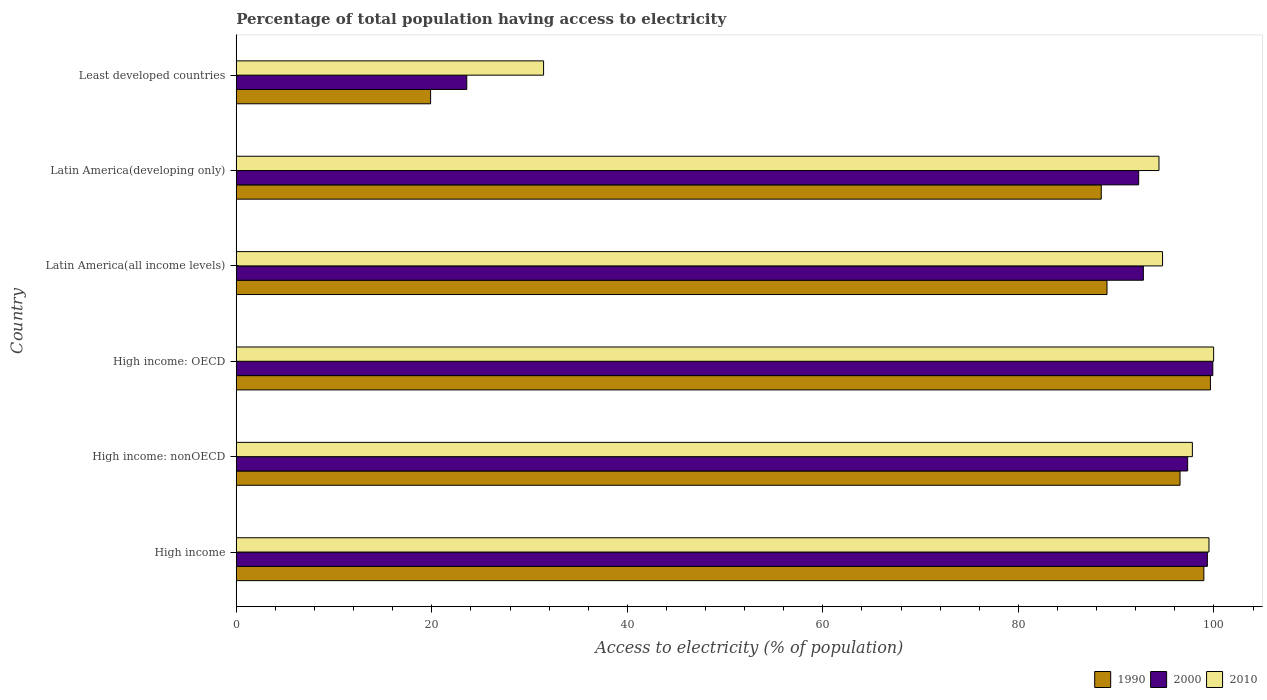Are the number of bars on each tick of the Y-axis equal?
Give a very brief answer. Yes. How many bars are there on the 3rd tick from the top?
Your answer should be very brief. 3. How many bars are there on the 2nd tick from the bottom?
Provide a short and direct response. 3. What is the label of the 2nd group of bars from the top?
Provide a succinct answer. Latin America(developing only). What is the percentage of population that have access to electricity in 1990 in Latin America(developing only)?
Make the answer very short. 88.48. Across all countries, what is the maximum percentage of population that have access to electricity in 2010?
Your answer should be compact. 99.97. Across all countries, what is the minimum percentage of population that have access to electricity in 2010?
Keep it short and to the point. 31.44. In which country was the percentage of population that have access to electricity in 2000 maximum?
Provide a succinct answer. High income: OECD. In which country was the percentage of population that have access to electricity in 2000 minimum?
Keep it short and to the point. Least developed countries. What is the total percentage of population that have access to electricity in 2000 in the graph?
Offer a very short reply. 505.2. What is the difference between the percentage of population that have access to electricity in 1990 in Latin America(all income levels) and that in Latin America(developing only)?
Offer a very short reply. 0.59. What is the difference between the percentage of population that have access to electricity in 2010 in High income: OECD and the percentage of population that have access to electricity in 2000 in Least developed countries?
Provide a short and direct response. 76.39. What is the average percentage of population that have access to electricity in 2010 per country?
Provide a short and direct response. 86.3. What is the difference between the percentage of population that have access to electricity in 2000 and percentage of population that have access to electricity in 2010 in Least developed countries?
Provide a succinct answer. -7.86. In how many countries, is the percentage of population that have access to electricity in 2010 greater than 88 %?
Make the answer very short. 5. What is the ratio of the percentage of population that have access to electricity in 2010 in Latin America(all income levels) to that in Least developed countries?
Ensure brevity in your answer.  3.01. What is the difference between the highest and the second highest percentage of population that have access to electricity in 1990?
Provide a short and direct response. 0.67. What is the difference between the highest and the lowest percentage of population that have access to electricity in 2000?
Offer a very short reply. 76.31. What does the 2nd bar from the top in Latin America(developing only) represents?
Make the answer very short. 2000. What does the 1st bar from the bottom in High income: nonOECD represents?
Make the answer very short. 1990. Is it the case that in every country, the sum of the percentage of population that have access to electricity in 2000 and percentage of population that have access to electricity in 1990 is greater than the percentage of population that have access to electricity in 2010?
Ensure brevity in your answer.  Yes. How many bars are there?
Make the answer very short. 18. Are all the bars in the graph horizontal?
Your answer should be very brief. Yes. How many countries are there in the graph?
Give a very brief answer. 6. What is the difference between two consecutive major ticks on the X-axis?
Provide a succinct answer. 20. Are the values on the major ticks of X-axis written in scientific E-notation?
Ensure brevity in your answer.  No. Does the graph contain any zero values?
Provide a succinct answer. No. Does the graph contain grids?
Ensure brevity in your answer.  No. How many legend labels are there?
Offer a very short reply. 3. How are the legend labels stacked?
Provide a short and direct response. Horizontal. What is the title of the graph?
Make the answer very short. Percentage of total population having access to electricity. Does "1960" appear as one of the legend labels in the graph?
Ensure brevity in your answer.  No. What is the label or title of the X-axis?
Offer a very short reply. Access to electricity (% of population). What is the Access to electricity (% of population) of 1990 in High income?
Provide a short and direct response. 98.97. What is the Access to electricity (% of population) in 2000 in High income?
Provide a short and direct response. 99.33. What is the Access to electricity (% of population) in 2010 in High income?
Ensure brevity in your answer.  99.49. What is the Access to electricity (% of population) of 1990 in High income: nonOECD?
Give a very brief answer. 96.53. What is the Access to electricity (% of population) in 2000 in High income: nonOECD?
Offer a terse response. 97.31. What is the Access to electricity (% of population) of 2010 in High income: nonOECD?
Give a very brief answer. 97.8. What is the Access to electricity (% of population) of 1990 in High income: OECD?
Provide a short and direct response. 99.64. What is the Access to electricity (% of population) of 2000 in High income: OECD?
Offer a terse response. 99.89. What is the Access to electricity (% of population) of 2010 in High income: OECD?
Your answer should be very brief. 99.97. What is the Access to electricity (% of population) in 1990 in Latin America(all income levels)?
Give a very brief answer. 89.06. What is the Access to electricity (% of population) of 2000 in Latin America(all income levels)?
Your answer should be compact. 92.78. What is the Access to electricity (% of population) in 2010 in Latin America(all income levels)?
Keep it short and to the point. 94.75. What is the Access to electricity (% of population) of 1990 in Latin America(developing only)?
Your answer should be very brief. 88.48. What is the Access to electricity (% of population) in 2000 in Latin America(developing only)?
Your answer should be very brief. 92.3. What is the Access to electricity (% of population) of 2010 in Latin America(developing only)?
Your answer should be very brief. 94.38. What is the Access to electricity (% of population) of 1990 in Least developed countries?
Ensure brevity in your answer.  19.88. What is the Access to electricity (% of population) of 2000 in Least developed countries?
Your answer should be very brief. 23.58. What is the Access to electricity (% of population) in 2010 in Least developed countries?
Provide a succinct answer. 31.44. Across all countries, what is the maximum Access to electricity (% of population) in 1990?
Provide a succinct answer. 99.64. Across all countries, what is the maximum Access to electricity (% of population) in 2000?
Keep it short and to the point. 99.89. Across all countries, what is the maximum Access to electricity (% of population) in 2010?
Offer a very short reply. 99.97. Across all countries, what is the minimum Access to electricity (% of population) in 1990?
Provide a succinct answer. 19.88. Across all countries, what is the minimum Access to electricity (% of population) in 2000?
Your answer should be compact. 23.58. Across all countries, what is the minimum Access to electricity (% of population) in 2010?
Keep it short and to the point. 31.44. What is the total Access to electricity (% of population) of 1990 in the graph?
Ensure brevity in your answer.  492.57. What is the total Access to electricity (% of population) in 2000 in the graph?
Make the answer very short. 505.2. What is the total Access to electricity (% of population) of 2010 in the graph?
Offer a terse response. 517.82. What is the difference between the Access to electricity (% of population) of 1990 in High income and that in High income: nonOECD?
Your response must be concise. 2.44. What is the difference between the Access to electricity (% of population) in 2000 in High income and that in High income: nonOECD?
Give a very brief answer. 2.02. What is the difference between the Access to electricity (% of population) of 2010 in High income and that in High income: nonOECD?
Offer a very short reply. 1.7. What is the difference between the Access to electricity (% of population) of 1990 in High income and that in High income: OECD?
Give a very brief answer. -0.67. What is the difference between the Access to electricity (% of population) in 2000 in High income and that in High income: OECD?
Your response must be concise. -0.56. What is the difference between the Access to electricity (% of population) of 2010 in High income and that in High income: OECD?
Your answer should be compact. -0.48. What is the difference between the Access to electricity (% of population) of 1990 in High income and that in Latin America(all income levels)?
Your answer should be compact. 9.91. What is the difference between the Access to electricity (% of population) of 2000 in High income and that in Latin America(all income levels)?
Your answer should be compact. 6.55. What is the difference between the Access to electricity (% of population) of 2010 in High income and that in Latin America(all income levels)?
Keep it short and to the point. 4.75. What is the difference between the Access to electricity (% of population) of 1990 in High income and that in Latin America(developing only)?
Provide a succinct answer. 10.49. What is the difference between the Access to electricity (% of population) in 2000 in High income and that in Latin America(developing only)?
Provide a succinct answer. 7.03. What is the difference between the Access to electricity (% of population) of 2010 in High income and that in Latin America(developing only)?
Ensure brevity in your answer.  5.12. What is the difference between the Access to electricity (% of population) in 1990 in High income and that in Least developed countries?
Offer a terse response. 79.09. What is the difference between the Access to electricity (% of population) of 2000 in High income and that in Least developed countries?
Your answer should be compact. 75.75. What is the difference between the Access to electricity (% of population) in 2010 in High income and that in Least developed countries?
Provide a succinct answer. 68.06. What is the difference between the Access to electricity (% of population) of 1990 in High income: nonOECD and that in High income: OECD?
Give a very brief answer. -3.11. What is the difference between the Access to electricity (% of population) of 2000 in High income: nonOECD and that in High income: OECD?
Ensure brevity in your answer.  -2.57. What is the difference between the Access to electricity (% of population) of 2010 in High income: nonOECD and that in High income: OECD?
Offer a terse response. -2.17. What is the difference between the Access to electricity (% of population) of 1990 in High income: nonOECD and that in Latin America(all income levels)?
Give a very brief answer. 7.47. What is the difference between the Access to electricity (% of population) of 2000 in High income: nonOECD and that in Latin America(all income levels)?
Provide a short and direct response. 4.53. What is the difference between the Access to electricity (% of population) in 2010 in High income: nonOECD and that in Latin America(all income levels)?
Give a very brief answer. 3.05. What is the difference between the Access to electricity (% of population) of 1990 in High income: nonOECD and that in Latin America(developing only)?
Ensure brevity in your answer.  8.06. What is the difference between the Access to electricity (% of population) of 2000 in High income: nonOECD and that in Latin America(developing only)?
Your answer should be very brief. 5.01. What is the difference between the Access to electricity (% of population) in 2010 in High income: nonOECD and that in Latin America(developing only)?
Provide a succinct answer. 3.42. What is the difference between the Access to electricity (% of population) of 1990 in High income: nonOECD and that in Least developed countries?
Provide a short and direct response. 76.66. What is the difference between the Access to electricity (% of population) of 2000 in High income: nonOECD and that in Least developed countries?
Ensure brevity in your answer.  73.73. What is the difference between the Access to electricity (% of population) in 2010 in High income: nonOECD and that in Least developed countries?
Offer a terse response. 66.36. What is the difference between the Access to electricity (% of population) of 1990 in High income: OECD and that in Latin America(all income levels)?
Provide a short and direct response. 10.58. What is the difference between the Access to electricity (% of population) of 2000 in High income: OECD and that in Latin America(all income levels)?
Make the answer very short. 7.1. What is the difference between the Access to electricity (% of population) of 2010 in High income: OECD and that in Latin America(all income levels)?
Make the answer very short. 5.22. What is the difference between the Access to electricity (% of population) of 1990 in High income: OECD and that in Latin America(developing only)?
Provide a short and direct response. 11.17. What is the difference between the Access to electricity (% of population) of 2000 in High income: OECD and that in Latin America(developing only)?
Ensure brevity in your answer.  7.58. What is the difference between the Access to electricity (% of population) of 2010 in High income: OECD and that in Latin America(developing only)?
Provide a succinct answer. 5.59. What is the difference between the Access to electricity (% of population) in 1990 in High income: OECD and that in Least developed countries?
Offer a terse response. 79.77. What is the difference between the Access to electricity (% of population) in 2000 in High income: OECD and that in Least developed countries?
Keep it short and to the point. 76.31. What is the difference between the Access to electricity (% of population) in 2010 in High income: OECD and that in Least developed countries?
Offer a terse response. 68.53. What is the difference between the Access to electricity (% of population) of 1990 in Latin America(all income levels) and that in Latin America(developing only)?
Ensure brevity in your answer.  0.59. What is the difference between the Access to electricity (% of population) in 2000 in Latin America(all income levels) and that in Latin America(developing only)?
Your answer should be compact. 0.48. What is the difference between the Access to electricity (% of population) in 2010 in Latin America(all income levels) and that in Latin America(developing only)?
Your answer should be very brief. 0.37. What is the difference between the Access to electricity (% of population) of 1990 in Latin America(all income levels) and that in Least developed countries?
Your answer should be very brief. 69.19. What is the difference between the Access to electricity (% of population) in 2000 in Latin America(all income levels) and that in Least developed countries?
Your response must be concise. 69.2. What is the difference between the Access to electricity (% of population) of 2010 in Latin America(all income levels) and that in Least developed countries?
Keep it short and to the point. 63.31. What is the difference between the Access to electricity (% of population) of 1990 in Latin America(developing only) and that in Least developed countries?
Provide a succinct answer. 68.6. What is the difference between the Access to electricity (% of population) in 2000 in Latin America(developing only) and that in Least developed countries?
Offer a terse response. 68.72. What is the difference between the Access to electricity (% of population) in 2010 in Latin America(developing only) and that in Least developed countries?
Keep it short and to the point. 62.94. What is the difference between the Access to electricity (% of population) of 1990 in High income and the Access to electricity (% of population) of 2000 in High income: nonOECD?
Your answer should be compact. 1.66. What is the difference between the Access to electricity (% of population) in 1990 in High income and the Access to electricity (% of population) in 2010 in High income: nonOECD?
Offer a very short reply. 1.18. What is the difference between the Access to electricity (% of population) of 2000 in High income and the Access to electricity (% of population) of 2010 in High income: nonOECD?
Ensure brevity in your answer.  1.53. What is the difference between the Access to electricity (% of population) of 1990 in High income and the Access to electricity (% of population) of 2000 in High income: OECD?
Your answer should be compact. -0.91. What is the difference between the Access to electricity (% of population) of 1990 in High income and the Access to electricity (% of population) of 2010 in High income: OECD?
Your answer should be compact. -1. What is the difference between the Access to electricity (% of population) of 2000 in High income and the Access to electricity (% of population) of 2010 in High income: OECD?
Provide a succinct answer. -0.64. What is the difference between the Access to electricity (% of population) in 1990 in High income and the Access to electricity (% of population) in 2000 in Latin America(all income levels)?
Ensure brevity in your answer.  6.19. What is the difference between the Access to electricity (% of population) in 1990 in High income and the Access to electricity (% of population) in 2010 in Latin America(all income levels)?
Provide a succinct answer. 4.23. What is the difference between the Access to electricity (% of population) in 2000 in High income and the Access to electricity (% of population) in 2010 in Latin America(all income levels)?
Your response must be concise. 4.59. What is the difference between the Access to electricity (% of population) of 1990 in High income and the Access to electricity (% of population) of 2000 in Latin America(developing only)?
Ensure brevity in your answer.  6.67. What is the difference between the Access to electricity (% of population) in 1990 in High income and the Access to electricity (% of population) in 2010 in Latin America(developing only)?
Offer a very short reply. 4.59. What is the difference between the Access to electricity (% of population) in 2000 in High income and the Access to electricity (% of population) in 2010 in Latin America(developing only)?
Your answer should be very brief. 4.95. What is the difference between the Access to electricity (% of population) in 1990 in High income and the Access to electricity (% of population) in 2000 in Least developed countries?
Give a very brief answer. 75.39. What is the difference between the Access to electricity (% of population) in 1990 in High income and the Access to electricity (% of population) in 2010 in Least developed countries?
Your answer should be compact. 67.54. What is the difference between the Access to electricity (% of population) in 2000 in High income and the Access to electricity (% of population) in 2010 in Least developed countries?
Your answer should be compact. 67.9. What is the difference between the Access to electricity (% of population) of 1990 in High income: nonOECD and the Access to electricity (% of population) of 2000 in High income: OECD?
Ensure brevity in your answer.  -3.35. What is the difference between the Access to electricity (% of population) in 1990 in High income: nonOECD and the Access to electricity (% of population) in 2010 in High income: OECD?
Make the answer very short. -3.44. What is the difference between the Access to electricity (% of population) in 2000 in High income: nonOECD and the Access to electricity (% of population) in 2010 in High income: OECD?
Make the answer very short. -2.66. What is the difference between the Access to electricity (% of population) in 1990 in High income: nonOECD and the Access to electricity (% of population) in 2000 in Latin America(all income levels)?
Make the answer very short. 3.75. What is the difference between the Access to electricity (% of population) in 1990 in High income: nonOECD and the Access to electricity (% of population) in 2010 in Latin America(all income levels)?
Offer a very short reply. 1.79. What is the difference between the Access to electricity (% of population) in 2000 in High income: nonOECD and the Access to electricity (% of population) in 2010 in Latin America(all income levels)?
Make the answer very short. 2.57. What is the difference between the Access to electricity (% of population) in 1990 in High income: nonOECD and the Access to electricity (% of population) in 2000 in Latin America(developing only)?
Your answer should be very brief. 4.23. What is the difference between the Access to electricity (% of population) of 1990 in High income: nonOECD and the Access to electricity (% of population) of 2010 in Latin America(developing only)?
Make the answer very short. 2.16. What is the difference between the Access to electricity (% of population) in 2000 in High income: nonOECD and the Access to electricity (% of population) in 2010 in Latin America(developing only)?
Make the answer very short. 2.94. What is the difference between the Access to electricity (% of population) in 1990 in High income: nonOECD and the Access to electricity (% of population) in 2000 in Least developed countries?
Provide a short and direct response. 72.95. What is the difference between the Access to electricity (% of population) of 1990 in High income: nonOECD and the Access to electricity (% of population) of 2010 in Least developed countries?
Give a very brief answer. 65.1. What is the difference between the Access to electricity (% of population) in 2000 in High income: nonOECD and the Access to electricity (% of population) in 2010 in Least developed countries?
Your answer should be very brief. 65.88. What is the difference between the Access to electricity (% of population) of 1990 in High income: OECD and the Access to electricity (% of population) of 2000 in Latin America(all income levels)?
Your answer should be compact. 6.86. What is the difference between the Access to electricity (% of population) of 1990 in High income: OECD and the Access to electricity (% of population) of 2010 in Latin America(all income levels)?
Give a very brief answer. 4.9. What is the difference between the Access to electricity (% of population) of 2000 in High income: OECD and the Access to electricity (% of population) of 2010 in Latin America(all income levels)?
Offer a very short reply. 5.14. What is the difference between the Access to electricity (% of population) of 1990 in High income: OECD and the Access to electricity (% of population) of 2000 in Latin America(developing only)?
Offer a terse response. 7.34. What is the difference between the Access to electricity (% of population) in 1990 in High income: OECD and the Access to electricity (% of population) in 2010 in Latin America(developing only)?
Your answer should be compact. 5.27. What is the difference between the Access to electricity (% of population) in 2000 in High income: OECD and the Access to electricity (% of population) in 2010 in Latin America(developing only)?
Your answer should be very brief. 5.51. What is the difference between the Access to electricity (% of population) in 1990 in High income: OECD and the Access to electricity (% of population) in 2000 in Least developed countries?
Your answer should be compact. 76.07. What is the difference between the Access to electricity (% of population) in 1990 in High income: OECD and the Access to electricity (% of population) in 2010 in Least developed countries?
Make the answer very short. 68.21. What is the difference between the Access to electricity (% of population) of 2000 in High income: OECD and the Access to electricity (% of population) of 2010 in Least developed countries?
Keep it short and to the point. 68.45. What is the difference between the Access to electricity (% of population) of 1990 in Latin America(all income levels) and the Access to electricity (% of population) of 2000 in Latin America(developing only)?
Offer a very short reply. -3.24. What is the difference between the Access to electricity (% of population) of 1990 in Latin America(all income levels) and the Access to electricity (% of population) of 2010 in Latin America(developing only)?
Your answer should be very brief. -5.32. What is the difference between the Access to electricity (% of population) in 2000 in Latin America(all income levels) and the Access to electricity (% of population) in 2010 in Latin America(developing only)?
Give a very brief answer. -1.6. What is the difference between the Access to electricity (% of population) of 1990 in Latin America(all income levels) and the Access to electricity (% of population) of 2000 in Least developed countries?
Your answer should be very brief. 65.48. What is the difference between the Access to electricity (% of population) in 1990 in Latin America(all income levels) and the Access to electricity (% of population) in 2010 in Least developed countries?
Offer a very short reply. 57.63. What is the difference between the Access to electricity (% of population) in 2000 in Latin America(all income levels) and the Access to electricity (% of population) in 2010 in Least developed countries?
Your answer should be compact. 61.35. What is the difference between the Access to electricity (% of population) in 1990 in Latin America(developing only) and the Access to electricity (% of population) in 2000 in Least developed countries?
Ensure brevity in your answer.  64.9. What is the difference between the Access to electricity (% of population) in 1990 in Latin America(developing only) and the Access to electricity (% of population) in 2010 in Least developed countries?
Provide a short and direct response. 57.04. What is the difference between the Access to electricity (% of population) in 2000 in Latin America(developing only) and the Access to electricity (% of population) in 2010 in Least developed countries?
Offer a terse response. 60.87. What is the average Access to electricity (% of population) of 1990 per country?
Offer a very short reply. 82.09. What is the average Access to electricity (% of population) of 2000 per country?
Your answer should be very brief. 84.2. What is the average Access to electricity (% of population) of 2010 per country?
Ensure brevity in your answer.  86.3. What is the difference between the Access to electricity (% of population) in 1990 and Access to electricity (% of population) in 2000 in High income?
Keep it short and to the point. -0.36. What is the difference between the Access to electricity (% of population) of 1990 and Access to electricity (% of population) of 2010 in High income?
Keep it short and to the point. -0.52. What is the difference between the Access to electricity (% of population) of 2000 and Access to electricity (% of population) of 2010 in High income?
Your answer should be very brief. -0.16. What is the difference between the Access to electricity (% of population) in 1990 and Access to electricity (% of population) in 2000 in High income: nonOECD?
Provide a succinct answer. -0.78. What is the difference between the Access to electricity (% of population) of 1990 and Access to electricity (% of population) of 2010 in High income: nonOECD?
Offer a very short reply. -1.26. What is the difference between the Access to electricity (% of population) in 2000 and Access to electricity (% of population) in 2010 in High income: nonOECD?
Your answer should be very brief. -0.48. What is the difference between the Access to electricity (% of population) in 1990 and Access to electricity (% of population) in 2000 in High income: OECD?
Provide a short and direct response. -0.24. What is the difference between the Access to electricity (% of population) of 1990 and Access to electricity (% of population) of 2010 in High income: OECD?
Ensure brevity in your answer.  -0.33. What is the difference between the Access to electricity (% of population) of 2000 and Access to electricity (% of population) of 2010 in High income: OECD?
Make the answer very short. -0.08. What is the difference between the Access to electricity (% of population) in 1990 and Access to electricity (% of population) in 2000 in Latin America(all income levels)?
Ensure brevity in your answer.  -3.72. What is the difference between the Access to electricity (% of population) in 1990 and Access to electricity (% of population) in 2010 in Latin America(all income levels)?
Make the answer very short. -5.68. What is the difference between the Access to electricity (% of population) of 2000 and Access to electricity (% of population) of 2010 in Latin America(all income levels)?
Provide a succinct answer. -1.96. What is the difference between the Access to electricity (% of population) of 1990 and Access to electricity (% of population) of 2000 in Latin America(developing only)?
Keep it short and to the point. -3.83. What is the difference between the Access to electricity (% of population) in 1990 and Access to electricity (% of population) in 2010 in Latin America(developing only)?
Your answer should be very brief. -5.9. What is the difference between the Access to electricity (% of population) of 2000 and Access to electricity (% of population) of 2010 in Latin America(developing only)?
Your answer should be very brief. -2.07. What is the difference between the Access to electricity (% of population) in 1990 and Access to electricity (% of population) in 2000 in Least developed countries?
Offer a terse response. -3.7. What is the difference between the Access to electricity (% of population) in 1990 and Access to electricity (% of population) in 2010 in Least developed countries?
Offer a very short reply. -11.56. What is the difference between the Access to electricity (% of population) of 2000 and Access to electricity (% of population) of 2010 in Least developed countries?
Ensure brevity in your answer.  -7.86. What is the ratio of the Access to electricity (% of population) of 1990 in High income to that in High income: nonOECD?
Offer a terse response. 1.03. What is the ratio of the Access to electricity (% of population) of 2000 in High income to that in High income: nonOECD?
Provide a short and direct response. 1.02. What is the ratio of the Access to electricity (% of population) in 2010 in High income to that in High income: nonOECD?
Your response must be concise. 1.02. What is the ratio of the Access to electricity (% of population) of 1990 in High income to that in High income: OECD?
Offer a very short reply. 0.99. What is the ratio of the Access to electricity (% of population) in 1990 in High income to that in Latin America(all income levels)?
Your answer should be compact. 1.11. What is the ratio of the Access to electricity (% of population) in 2000 in High income to that in Latin America(all income levels)?
Offer a very short reply. 1.07. What is the ratio of the Access to electricity (% of population) in 2010 in High income to that in Latin America(all income levels)?
Offer a terse response. 1.05. What is the ratio of the Access to electricity (% of population) in 1990 in High income to that in Latin America(developing only)?
Provide a short and direct response. 1.12. What is the ratio of the Access to electricity (% of population) in 2000 in High income to that in Latin America(developing only)?
Offer a very short reply. 1.08. What is the ratio of the Access to electricity (% of population) of 2010 in High income to that in Latin America(developing only)?
Keep it short and to the point. 1.05. What is the ratio of the Access to electricity (% of population) in 1990 in High income to that in Least developed countries?
Your answer should be very brief. 4.98. What is the ratio of the Access to electricity (% of population) of 2000 in High income to that in Least developed countries?
Provide a succinct answer. 4.21. What is the ratio of the Access to electricity (% of population) in 2010 in High income to that in Least developed countries?
Give a very brief answer. 3.17. What is the ratio of the Access to electricity (% of population) in 1990 in High income: nonOECD to that in High income: OECD?
Give a very brief answer. 0.97. What is the ratio of the Access to electricity (% of population) in 2000 in High income: nonOECD to that in High income: OECD?
Keep it short and to the point. 0.97. What is the ratio of the Access to electricity (% of population) in 2010 in High income: nonOECD to that in High income: OECD?
Ensure brevity in your answer.  0.98. What is the ratio of the Access to electricity (% of population) of 1990 in High income: nonOECD to that in Latin America(all income levels)?
Offer a terse response. 1.08. What is the ratio of the Access to electricity (% of population) of 2000 in High income: nonOECD to that in Latin America(all income levels)?
Your answer should be compact. 1.05. What is the ratio of the Access to electricity (% of population) in 2010 in High income: nonOECD to that in Latin America(all income levels)?
Offer a terse response. 1.03. What is the ratio of the Access to electricity (% of population) in 1990 in High income: nonOECD to that in Latin America(developing only)?
Keep it short and to the point. 1.09. What is the ratio of the Access to electricity (% of population) in 2000 in High income: nonOECD to that in Latin America(developing only)?
Offer a very short reply. 1.05. What is the ratio of the Access to electricity (% of population) of 2010 in High income: nonOECD to that in Latin America(developing only)?
Provide a succinct answer. 1.04. What is the ratio of the Access to electricity (% of population) of 1990 in High income: nonOECD to that in Least developed countries?
Offer a very short reply. 4.86. What is the ratio of the Access to electricity (% of population) of 2000 in High income: nonOECD to that in Least developed countries?
Your answer should be very brief. 4.13. What is the ratio of the Access to electricity (% of population) of 2010 in High income: nonOECD to that in Least developed countries?
Provide a short and direct response. 3.11. What is the ratio of the Access to electricity (% of population) in 1990 in High income: OECD to that in Latin America(all income levels)?
Give a very brief answer. 1.12. What is the ratio of the Access to electricity (% of population) in 2000 in High income: OECD to that in Latin America(all income levels)?
Your answer should be very brief. 1.08. What is the ratio of the Access to electricity (% of population) in 2010 in High income: OECD to that in Latin America(all income levels)?
Give a very brief answer. 1.06. What is the ratio of the Access to electricity (% of population) of 1990 in High income: OECD to that in Latin America(developing only)?
Your response must be concise. 1.13. What is the ratio of the Access to electricity (% of population) in 2000 in High income: OECD to that in Latin America(developing only)?
Offer a very short reply. 1.08. What is the ratio of the Access to electricity (% of population) of 2010 in High income: OECD to that in Latin America(developing only)?
Your answer should be very brief. 1.06. What is the ratio of the Access to electricity (% of population) in 1990 in High income: OECD to that in Least developed countries?
Your response must be concise. 5.01. What is the ratio of the Access to electricity (% of population) of 2000 in High income: OECD to that in Least developed countries?
Provide a succinct answer. 4.24. What is the ratio of the Access to electricity (% of population) in 2010 in High income: OECD to that in Least developed countries?
Ensure brevity in your answer.  3.18. What is the ratio of the Access to electricity (% of population) in 1990 in Latin America(all income levels) to that in Latin America(developing only)?
Keep it short and to the point. 1.01. What is the ratio of the Access to electricity (% of population) in 1990 in Latin America(all income levels) to that in Least developed countries?
Your answer should be very brief. 4.48. What is the ratio of the Access to electricity (% of population) in 2000 in Latin America(all income levels) to that in Least developed countries?
Ensure brevity in your answer.  3.94. What is the ratio of the Access to electricity (% of population) of 2010 in Latin America(all income levels) to that in Least developed countries?
Make the answer very short. 3.01. What is the ratio of the Access to electricity (% of population) of 1990 in Latin America(developing only) to that in Least developed countries?
Ensure brevity in your answer.  4.45. What is the ratio of the Access to electricity (% of population) in 2000 in Latin America(developing only) to that in Least developed countries?
Ensure brevity in your answer.  3.91. What is the ratio of the Access to electricity (% of population) of 2010 in Latin America(developing only) to that in Least developed countries?
Make the answer very short. 3. What is the difference between the highest and the second highest Access to electricity (% of population) of 1990?
Your response must be concise. 0.67. What is the difference between the highest and the second highest Access to electricity (% of population) in 2000?
Your answer should be compact. 0.56. What is the difference between the highest and the second highest Access to electricity (% of population) in 2010?
Your response must be concise. 0.48. What is the difference between the highest and the lowest Access to electricity (% of population) in 1990?
Make the answer very short. 79.77. What is the difference between the highest and the lowest Access to electricity (% of population) of 2000?
Offer a terse response. 76.31. What is the difference between the highest and the lowest Access to electricity (% of population) in 2010?
Your answer should be very brief. 68.53. 